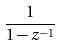Convert formula to latex. <formula><loc_0><loc_0><loc_500><loc_500>\frac { 1 } { 1 - z ^ { - 1 } }</formula> 